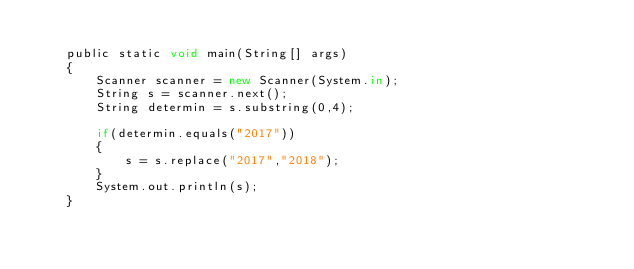Convert code to text. <code><loc_0><loc_0><loc_500><loc_500><_JavaScript_>
	public static void main(String[] args)
	{
		Scanner scanner = new Scanner(System.in);
		String s = scanner.next();
		String determin = s.substring(0,4);

		if(determin.equals("2017"))
		{
			s = s.replace("2017","2018");
		}
		System.out.println(s);
	}	

</code> 